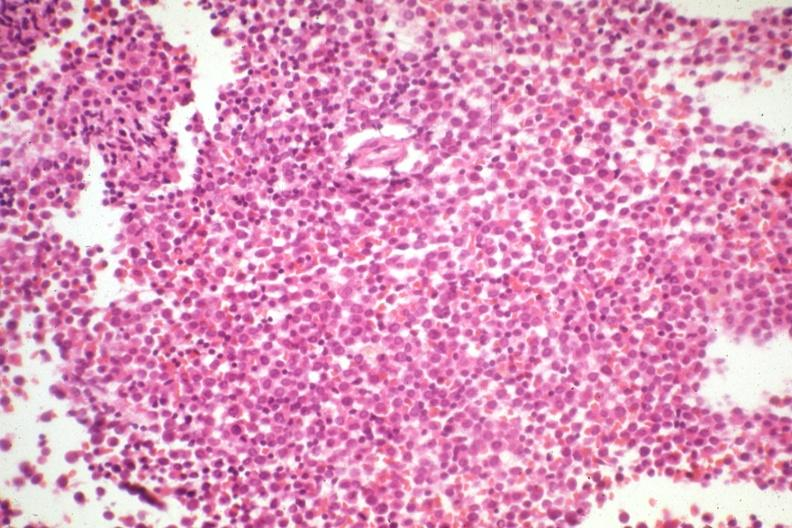what is present?
Answer the question using a single word or phrase. Hematologic 